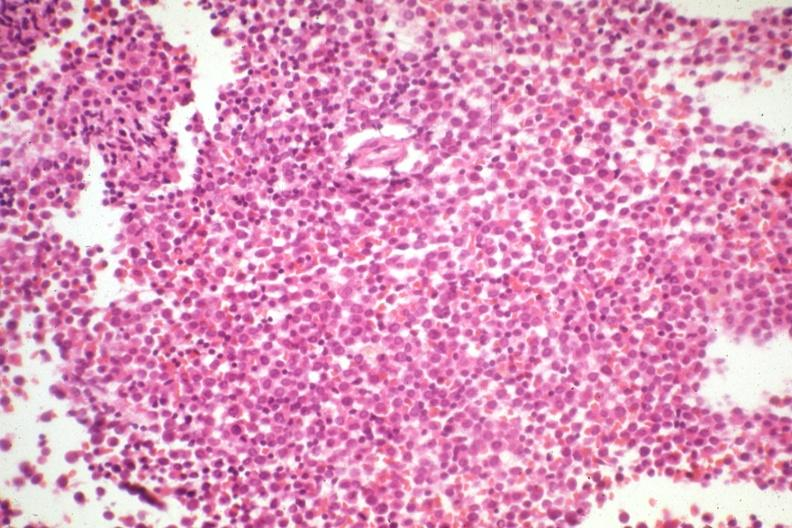what is present?
Answer the question using a single word or phrase. Hematologic 